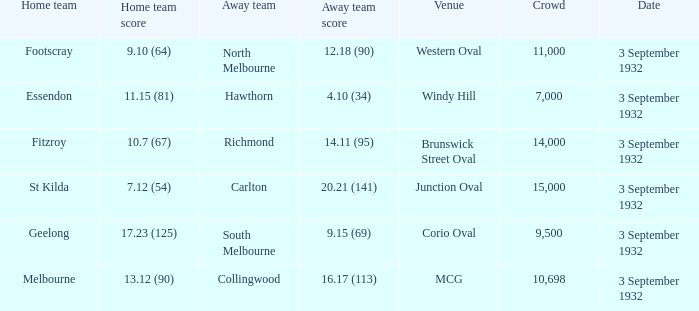What is the total Crowd number for the team that has an Away team score of 12.18 (90)? 11000.0. 